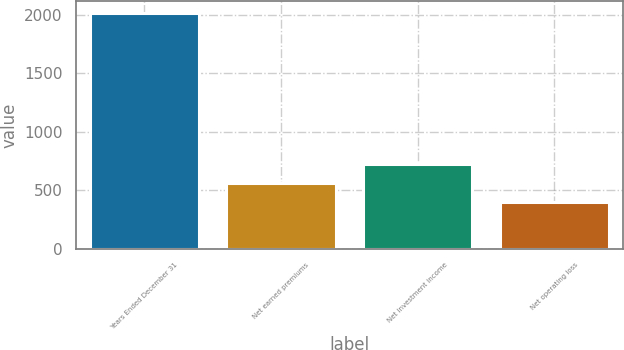<chart> <loc_0><loc_0><loc_500><loc_500><bar_chart><fcel>Years Ended December 31<fcel>Net earned premiums<fcel>Net investment income<fcel>Net operating loss<nl><fcel>2015<fcel>560.6<fcel>722.2<fcel>399<nl></chart> 